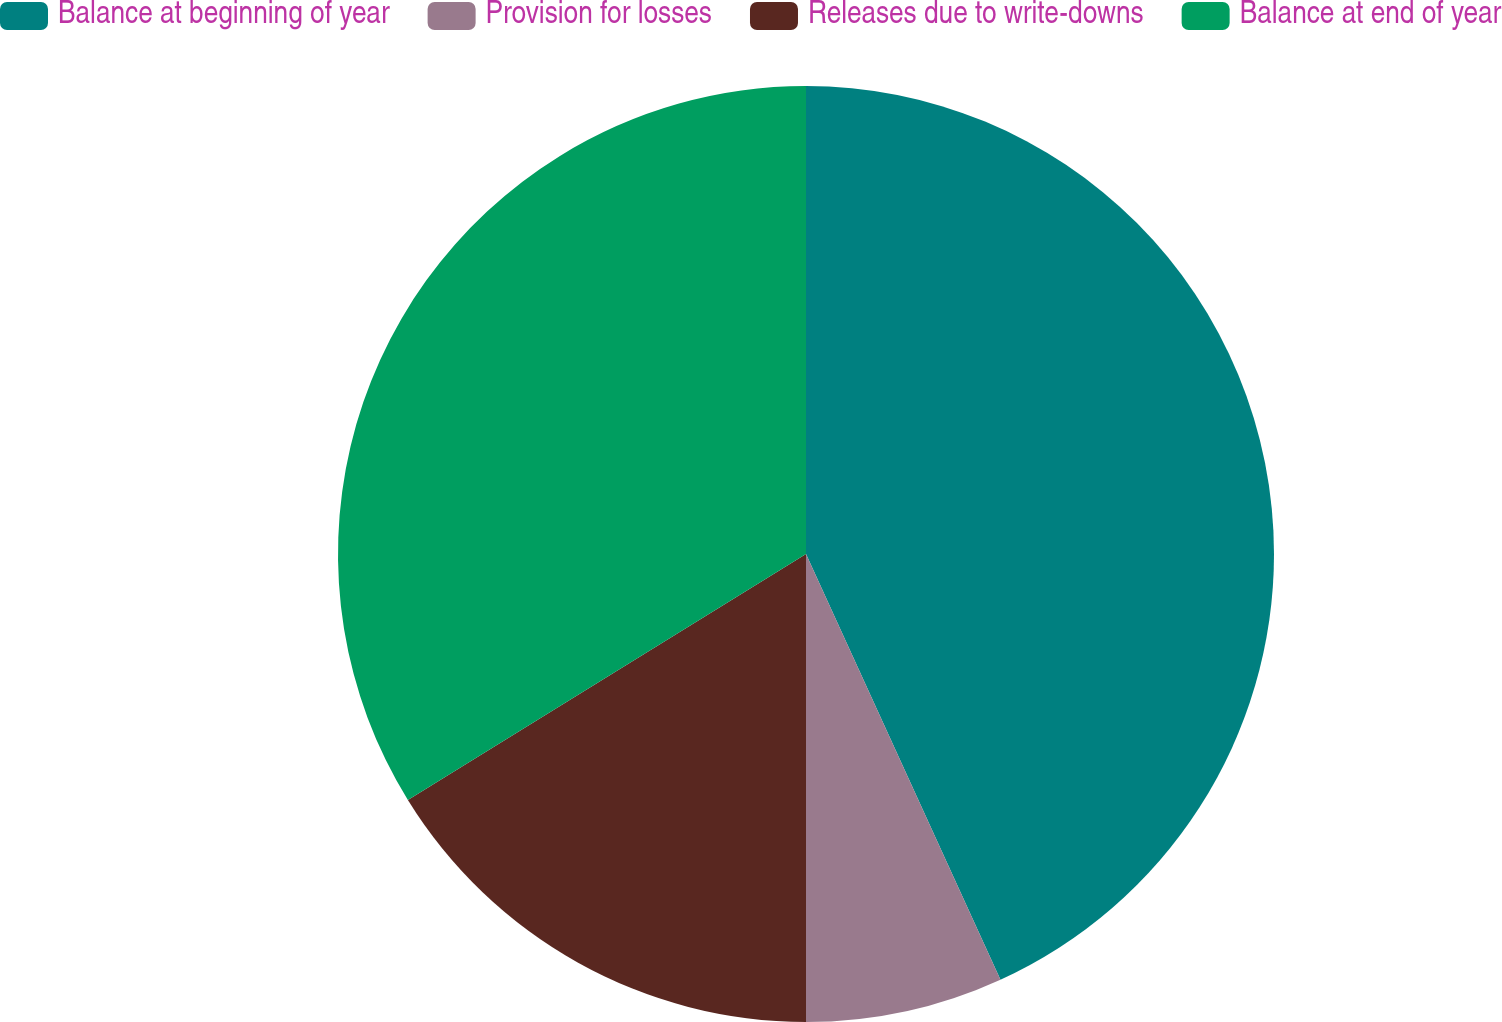<chart> <loc_0><loc_0><loc_500><loc_500><pie_chart><fcel>Balance at beginning of year<fcel>Provision for losses<fcel>Releases due to write-downs<fcel>Balance at end of year<nl><fcel>43.18%<fcel>6.82%<fcel>16.19%<fcel>33.81%<nl></chart> 